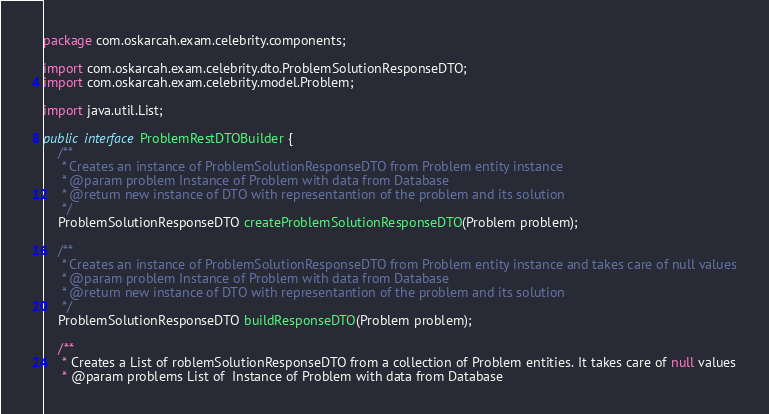Convert code to text. <code><loc_0><loc_0><loc_500><loc_500><_Java_>package com.oskarcah.exam.celebrity.components;

import com.oskarcah.exam.celebrity.dto.ProblemSolutionResponseDTO;
import com.oskarcah.exam.celebrity.model.Problem;

import java.util.List;

public interface ProblemRestDTOBuilder {
    /**
     * Creates an instance of ProblemSolutionResponseDTO from Problem entity instance
     * @param problem Instance of Problem with data from Database
     * @return new instance of DTO with representantion of the problem and its solution
     */
    ProblemSolutionResponseDTO createProblemSolutionResponseDTO(Problem problem);

    /**
     * Creates an instance of ProblemSolutionResponseDTO from Problem entity instance and takes care of null values
     * @param problem Instance of Problem with data from Database
     * @return new instance of DTO with representantion of the problem and its solution
     */
    ProblemSolutionResponseDTO buildResponseDTO(Problem problem);

    /**
     * Creates a List of roblemSolutionResponseDTO from a collection of Problem entities. It takes care of null values
     * @param problems List of  Instance of Problem with data from Database</code> 